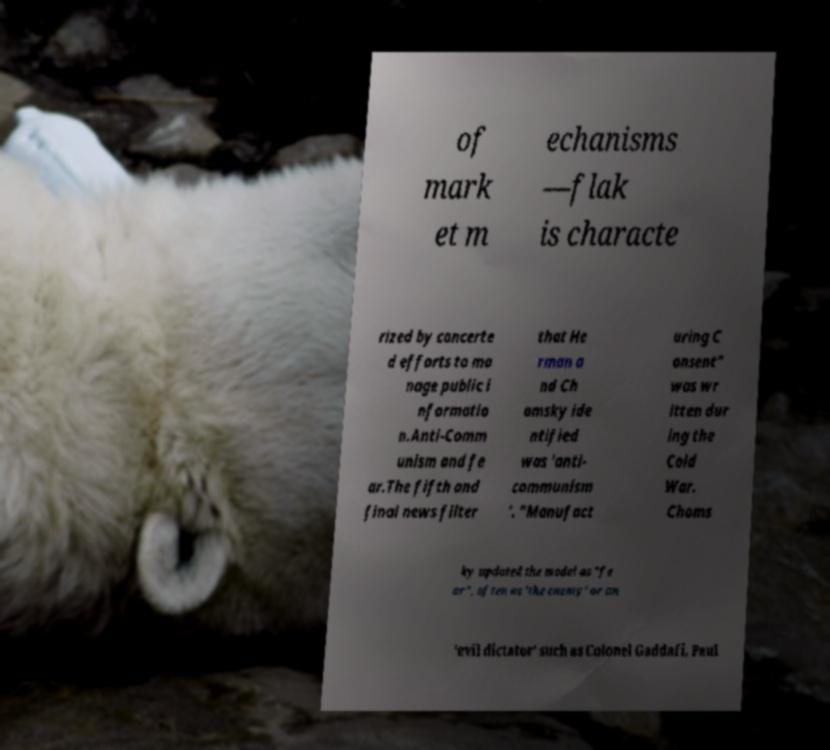Please read and relay the text visible in this image. What does it say? of mark et m echanisms —flak is characte rized by concerte d efforts to ma nage public i nformatio n.Anti-Comm unism and fe ar.The fifth and final news filter that He rman a nd Ch omsky ide ntified was 'anti- communism '. "Manufact uring C onsent" was wr itten dur ing the Cold War. Choms ky updated the model as "fe ar", often as 'the enemy' or an 'evil dictator' such as Colonel Gaddafi, Paul 